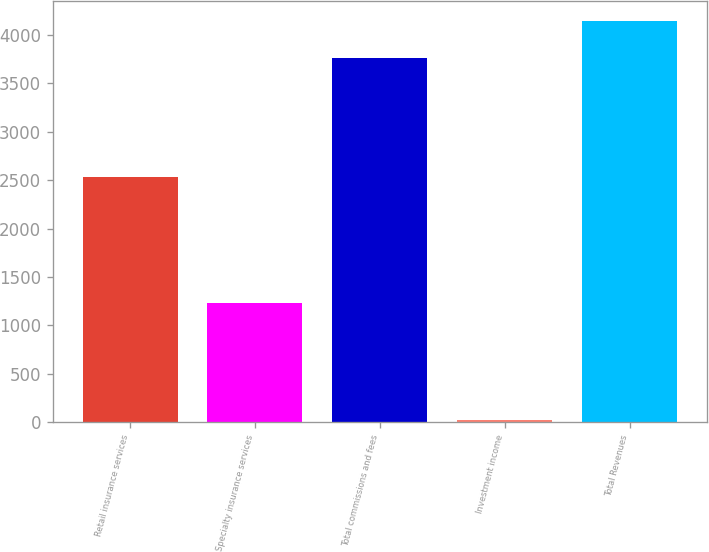Convert chart. <chart><loc_0><loc_0><loc_500><loc_500><bar_chart><fcel>Retail insurance services<fcel>Specialty insurance services<fcel>Total commissions and fees<fcel>Investment income<fcel>Total Revenues<nl><fcel>2534<fcel>1233<fcel>3767<fcel>16<fcel>4145.6<nl></chart> 